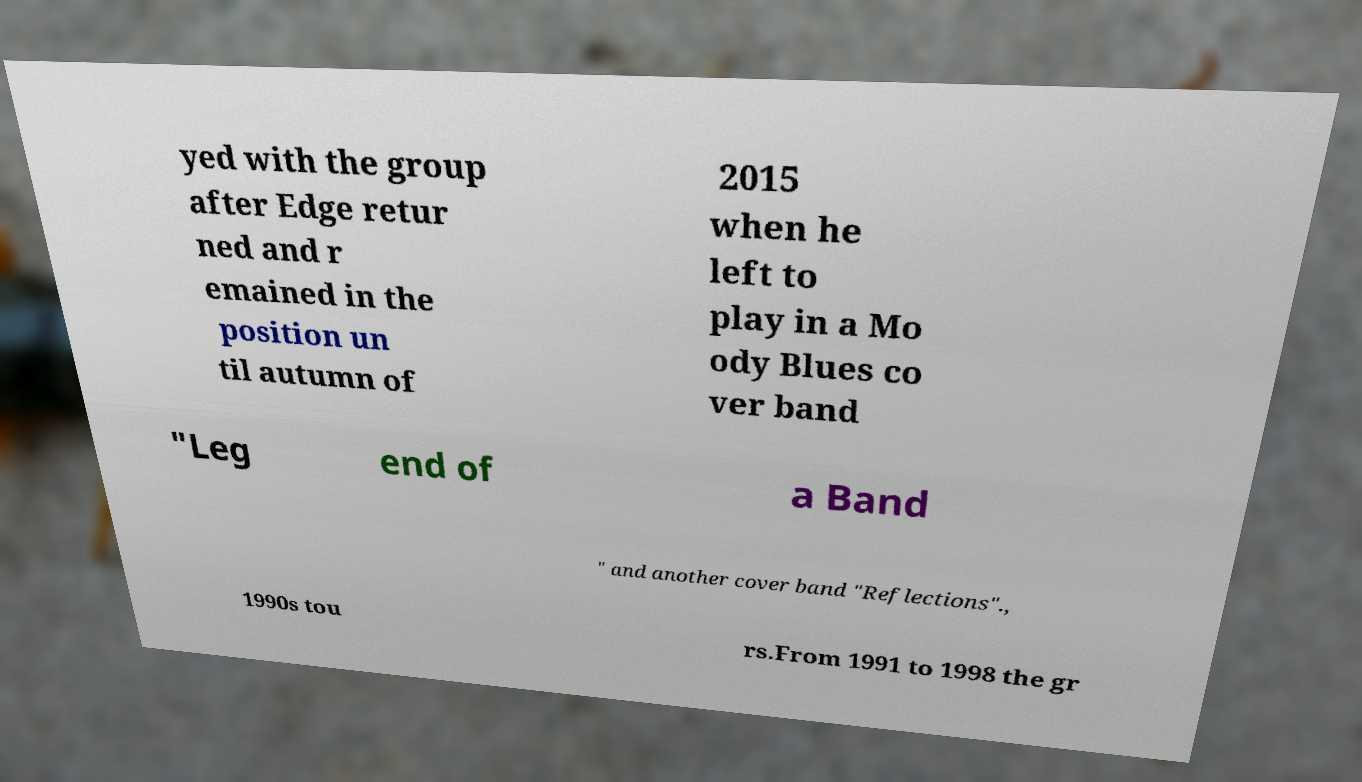Can you read and provide the text displayed in the image?This photo seems to have some interesting text. Can you extract and type it out for me? yed with the group after Edge retur ned and r emained in the position un til autumn of 2015 when he left to play in a Mo ody Blues co ver band "Leg end of a Band " and another cover band "Reflections"., 1990s tou rs.From 1991 to 1998 the gr 